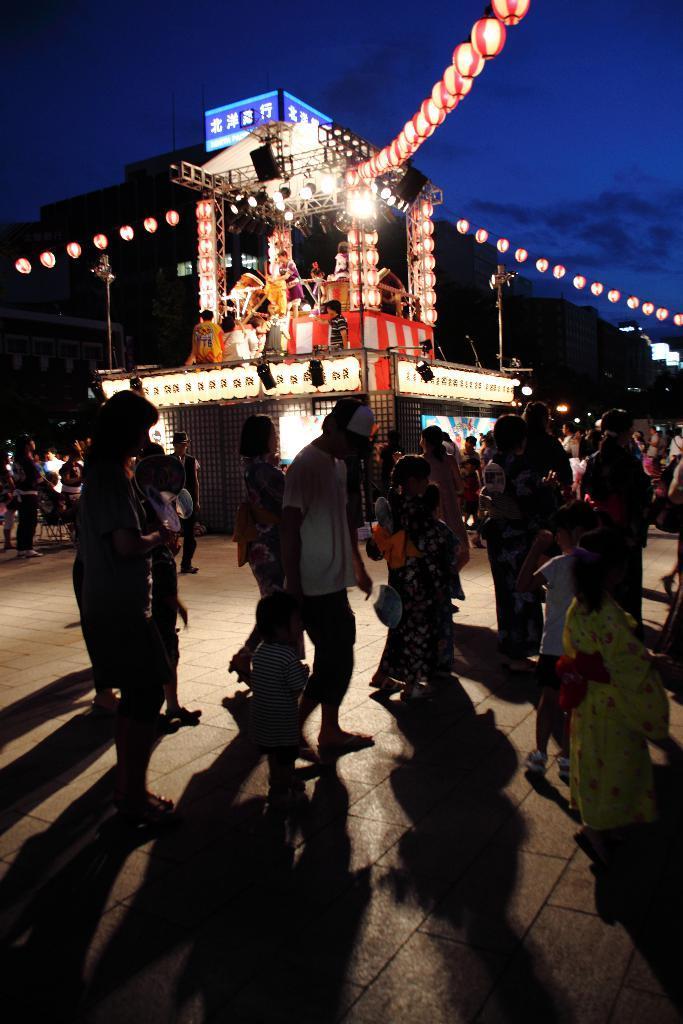How would you summarize this image in a sentence or two? There are some persons on the road. Here we can see lights, poles, boards, and buildings. In the background there is sky. 